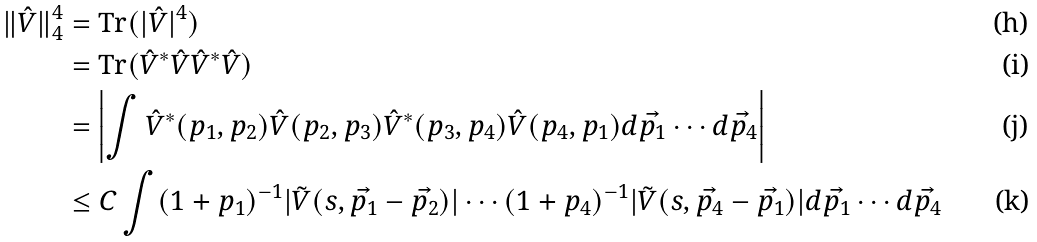<formula> <loc_0><loc_0><loc_500><loc_500>\| \hat { V } \| _ { 4 } ^ { 4 } & = \text {Tr} ( | \hat { V } | ^ { 4 } ) \\ & = \text {Tr} ( \hat { V } ^ { * } \hat { V } \hat { V } ^ { * } \hat { V } ) \\ & = \left | \int \hat { V } ^ { * } ( p _ { 1 } , p _ { 2 } ) \hat { V } ( p _ { 2 } , p _ { 3 } ) \hat { V } ^ { * } ( p _ { 3 } , p _ { 4 } ) \hat { V } ( p _ { 4 } , p _ { 1 } ) d \vec { p _ { 1 } } \cdots d \vec { p _ { 4 } } \right | \\ & \leq C \int ( 1 + p _ { 1 } ) ^ { - 1 } | \tilde { V } ( s , \vec { p _ { 1 } } - \vec { p _ { 2 } } ) | \cdots ( 1 + p _ { 4 } ) ^ { - 1 } | \tilde { V } ( s , \vec { p _ { 4 } } - \vec { p _ { 1 } } ) | d \vec { p _ { 1 } } \cdots d \vec { p _ { 4 } }</formula> 